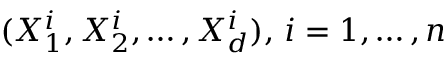Convert formula to latex. <formula><loc_0><loc_0><loc_500><loc_500>( X _ { 1 } ^ { i } , X _ { 2 } ^ { i } , \dots , X _ { d } ^ { i } ) , \, i = 1 , \dots , n</formula> 